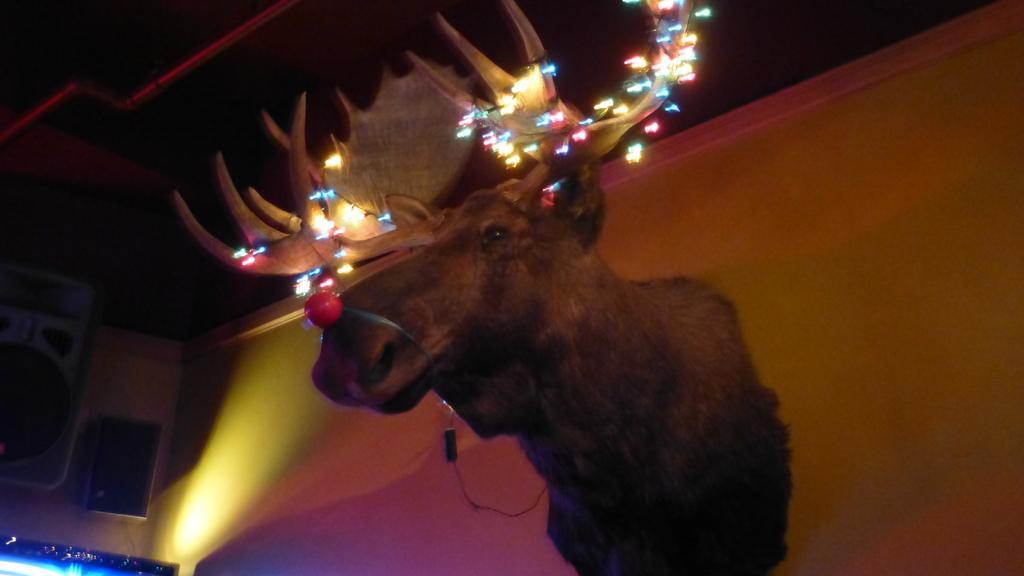How would you summarize this image in a sentence or two? In the image on the wall there is a statue of an animal. On the horns of the animal there are decorative lights. In the background there are speakers, lights and some other things. 